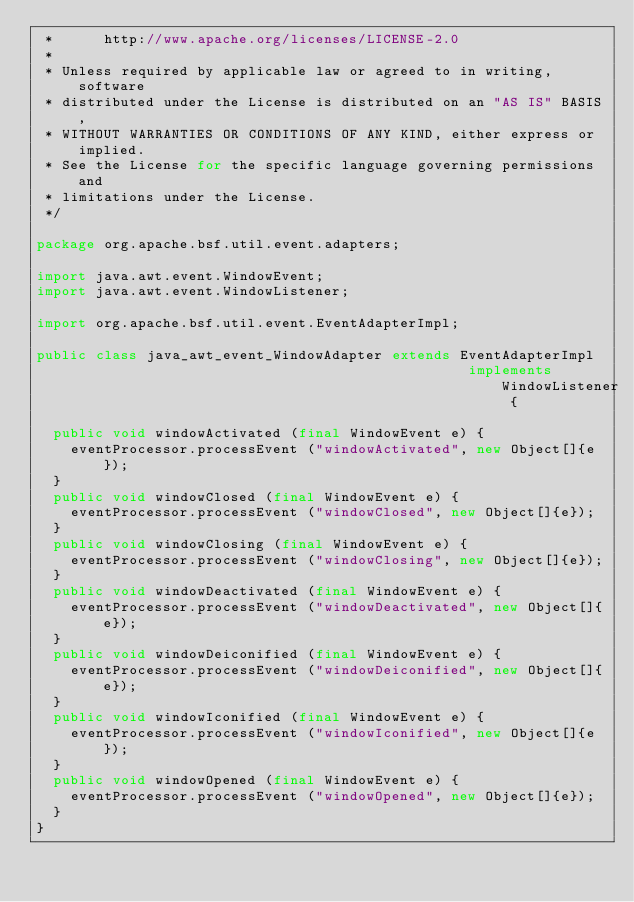Convert code to text. <code><loc_0><loc_0><loc_500><loc_500><_Java_> *      http://www.apache.org/licenses/LICENSE-2.0
 * 
 * Unless required by applicable law or agreed to in writing, software
 * distributed under the License is distributed on an "AS IS" BASIS,
 * WITHOUT WARRANTIES OR CONDITIONS OF ANY KIND, either express or implied.
 * See the License for the specific language governing permissions and
 * limitations under the License.
 */

package org.apache.bsf.util.event.adapters;

import java.awt.event.WindowEvent;
import java.awt.event.WindowListener;

import org.apache.bsf.util.event.EventAdapterImpl;

public class java_awt_event_WindowAdapter extends EventAdapterImpl
                                                   implements WindowListener {

  public void windowActivated (final WindowEvent e) {
    eventProcessor.processEvent ("windowActivated", new Object[]{e});
  }
  public void windowClosed (final WindowEvent e) {
    eventProcessor.processEvent ("windowClosed", new Object[]{e});
  }
  public void windowClosing (final WindowEvent e) {
    eventProcessor.processEvent ("windowClosing", new Object[]{e});
  }
  public void windowDeactivated (final WindowEvent e) {
    eventProcessor.processEvent ("windowDeactivated", new Object[]{e});
  }
  public void windowDeiconified (final WindowEvent e) {
    eventProcessor.processEvent ("windowDeiconified", new Object[]{e});
  }
  public void windowIconified (final WindowEvent e) {
    eventProcessor.processEvent ("windowIconified", new Object[]{e});
  }
  public void windowOpened (final WindowEvent e) {
    eventProcessor.processEvent ("windowOpened", new Object[]{e});
  }
}
</code> 